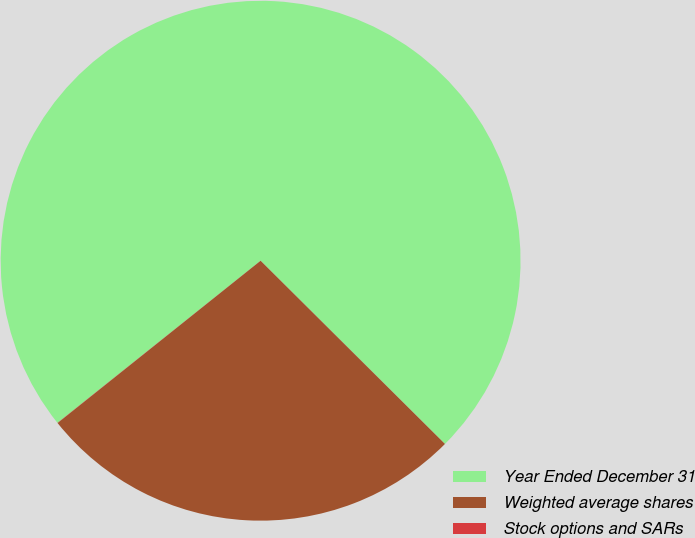Convert chart to OTSL. <chart><loc_0><loc_0><loc_500><loc_500><pie_chart><fcel>Year Ended December 31<fcel>Weighted average shares<fcel>Stock options and SARs<nl><fcel>73.18%<fcel>26.82%<fcel>0.01%<nl></chart> 